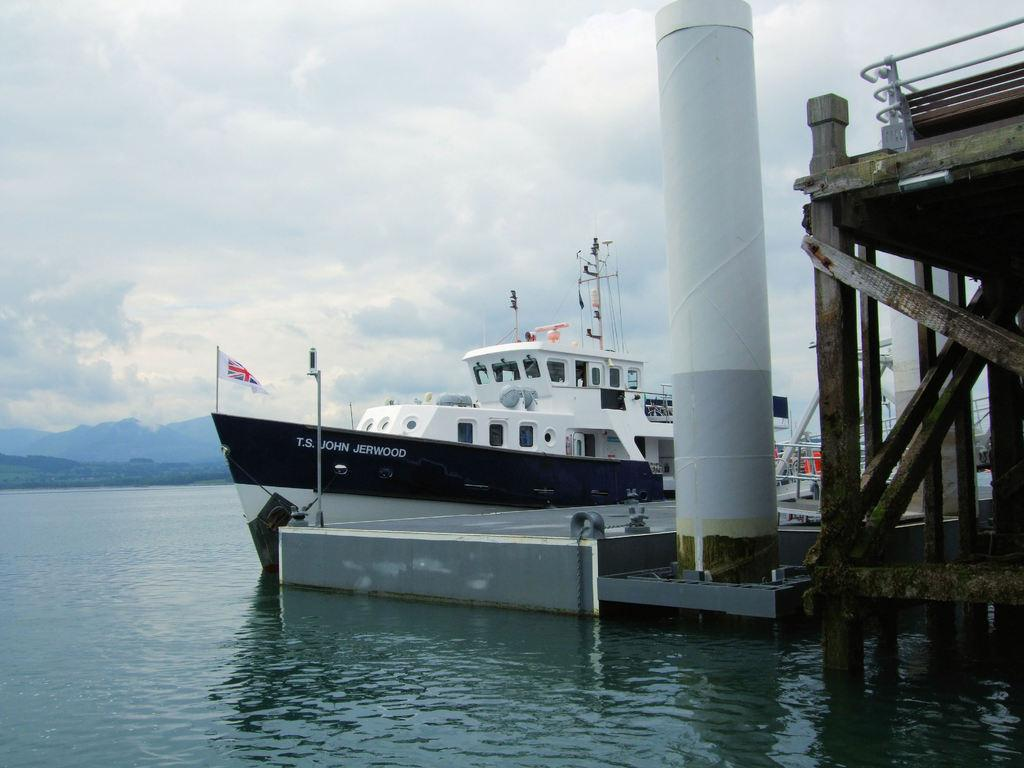<image>
Offer a succinct explanation of the picture presented. A ship at a dock that reads T.S. JOHN JERWOOD. 